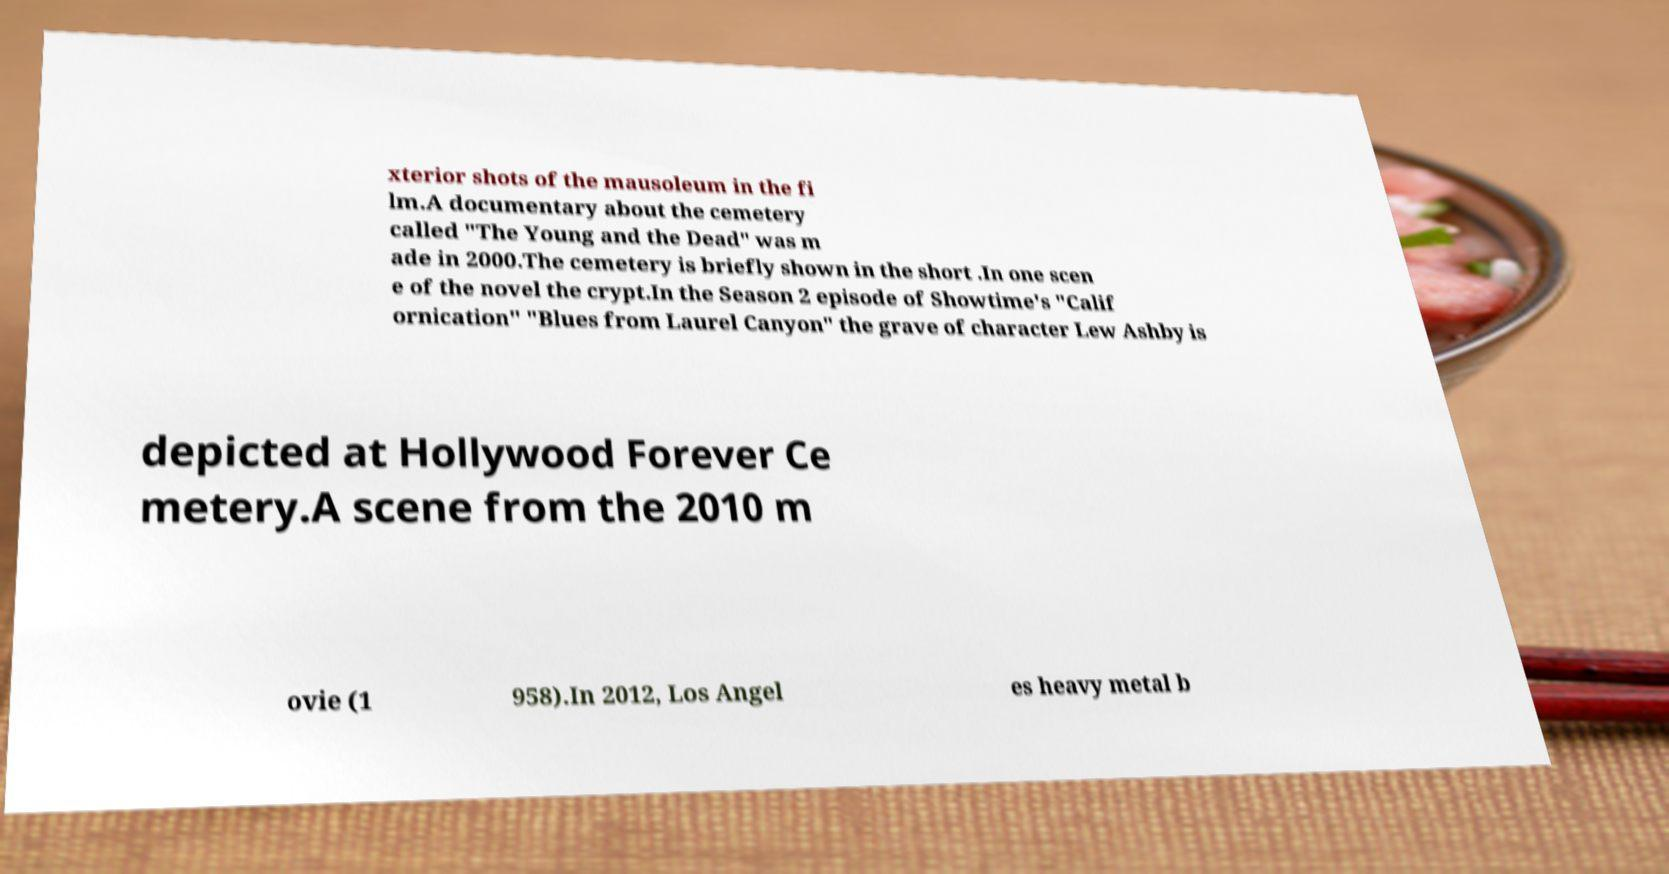Could you extract and type out the text from this image? xterior shots of the mausoleum in the fi lm.A documentary about the cemetery called "The Young and the Dead" was m ade in 2000.The cemetery is briefly shown in the short .In one scen e of the novel the crypt.In the Season 2 episode of Showtime's "Calif ornication" "Blues from Laurel Canyon" the grave of character Lew Ashby is depicted at Hollywood Forever Ce metery.A scene from the 2010 m ovie (1 958).In 2012, Los Angel es heavy metal b 